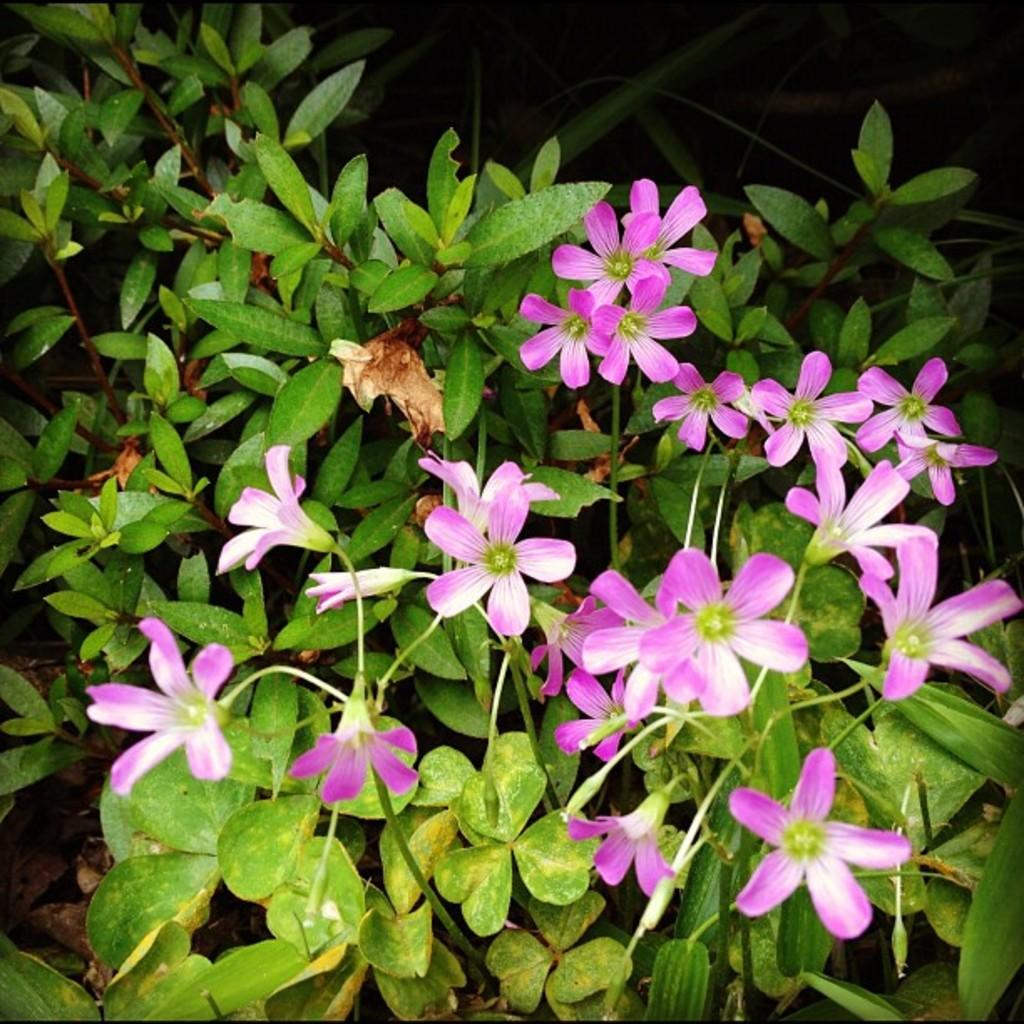What type of living organisms can be seen in the image? Plants and flowers are visible in the image. Where are the plants and flowers located in the image? The plants and flowers are in the center of the image. What colors are the flowers in the image? The flowers are pink and white in color. Is there a writer sitting on the flowers in the image? No, there is no writer present in the image, and the flowers are not being sat on. 